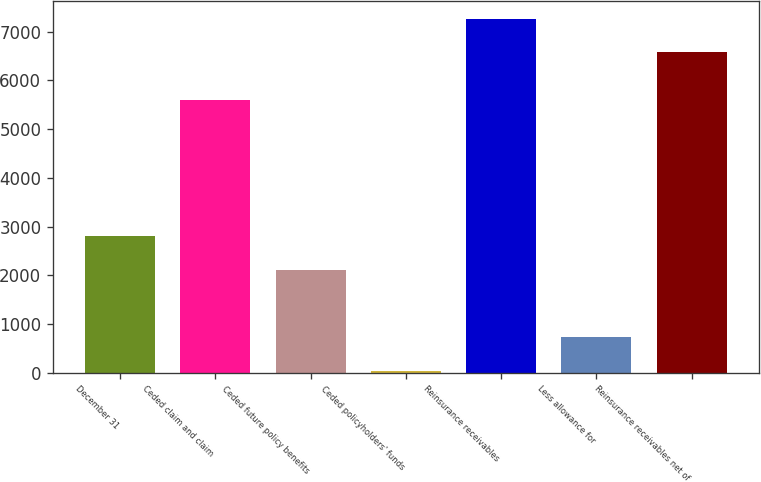Convert chart to OTSL. <chart><loc_0><loc_0><loc_500><loc_500><bar_chart><fcel>December 31<fcel>Ceded claim and claim<fcel>Ceded future policy benefits<fcel>Ceded policyholders' funds<fcel>Reinsurance receivables<fcel>Less allowance for<fcel>Reinsurance receivables net of<nl><fcel>2796.2<fcel>5594<fcel>2106.9<fcel>39<fcel>7270.3<fcel>728.3<fcel>6581<nl></chart> 